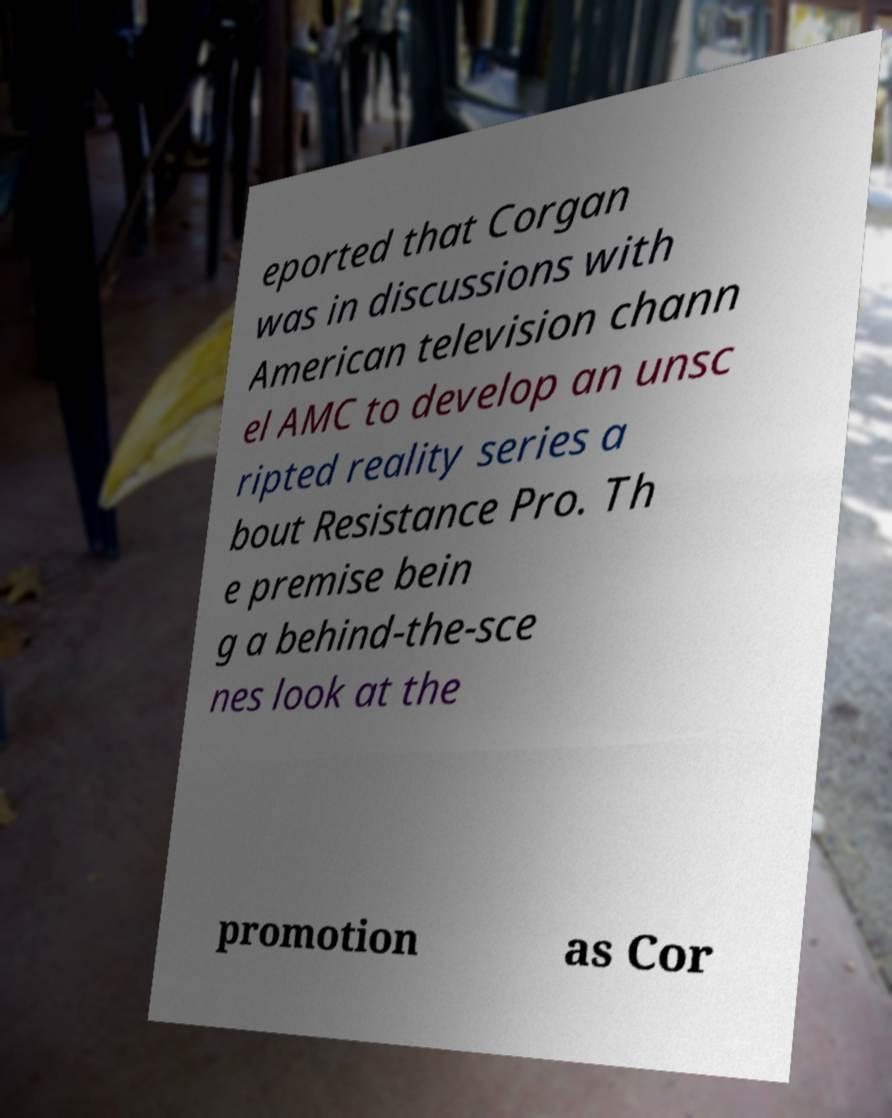Please identify and transcribe the text found in this image. eported that Corgan was in discussions with American television chann el AMC to develop an unsc ripted reality series a bout Resistance Pro. Th e premise bein g a behind-the-sce nes look at the promotion as Cor 